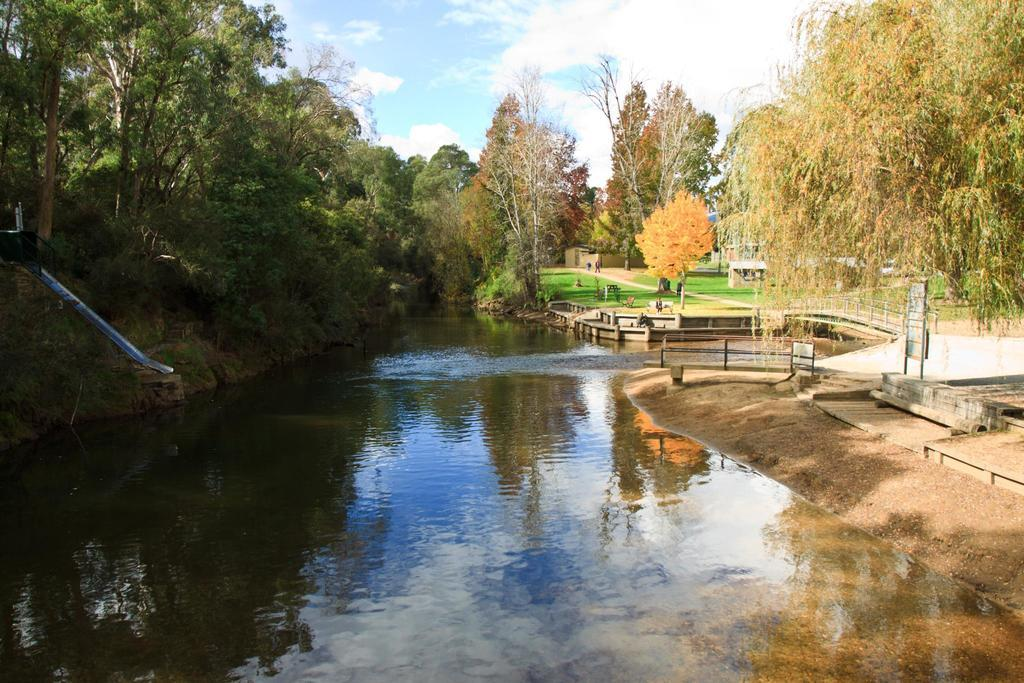What is the main feature in the center of the image? There is a canal in the center of the image. What can be seen in the background of the image? There are trees in the background of the image. What is located on the right side of the image? There are boards on the right side of the image. What is visible at the top of the image? The sky is visible at the top of the image. How many crows are perched on the rail in the image? There is no rail or crow present in the image. 